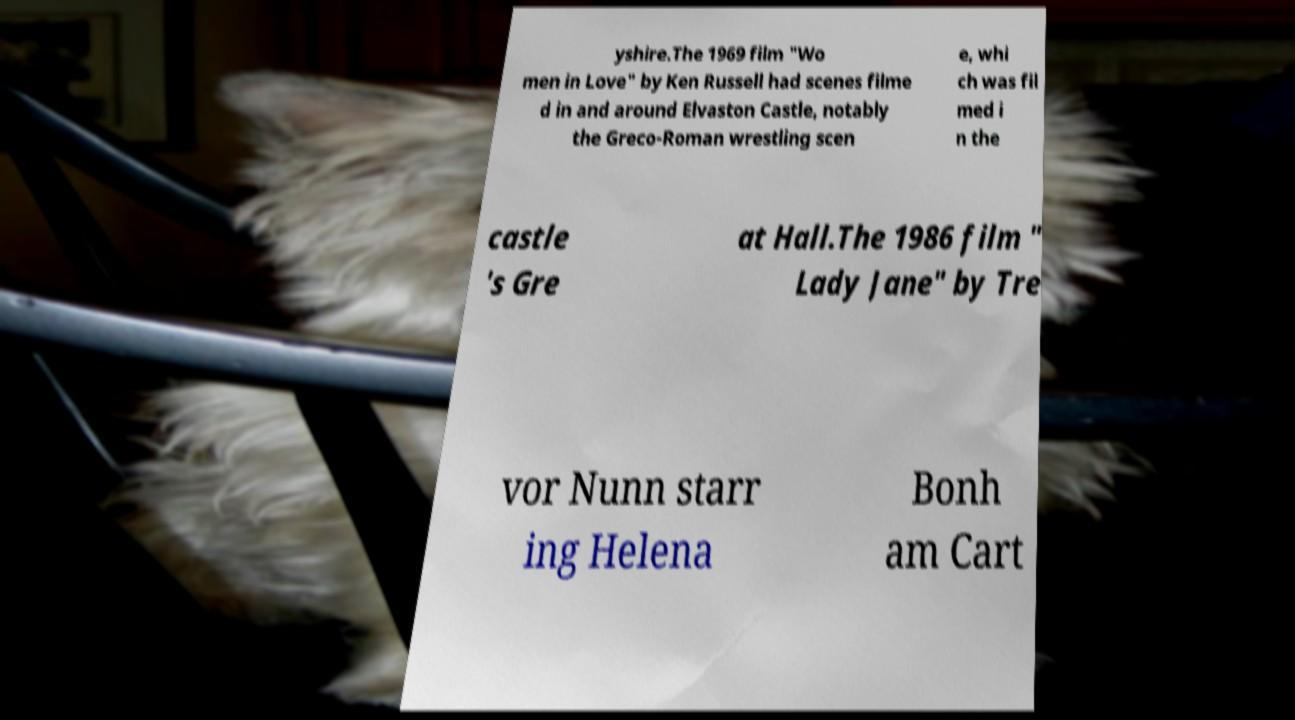Please read and relay the text visible in this image. What does it say? yshire.The 1969 film "Wo men in Love" by Ken Russell had scenes filme d in and around Elvaston Castle, notably the Greco-Roman wrestling scen e, whi ch was fil med i n the castle 's Gre at Hall.The 1986 film " Lady Jane" by Tre vor Nunn starr ing Helena Bonh am Cart 